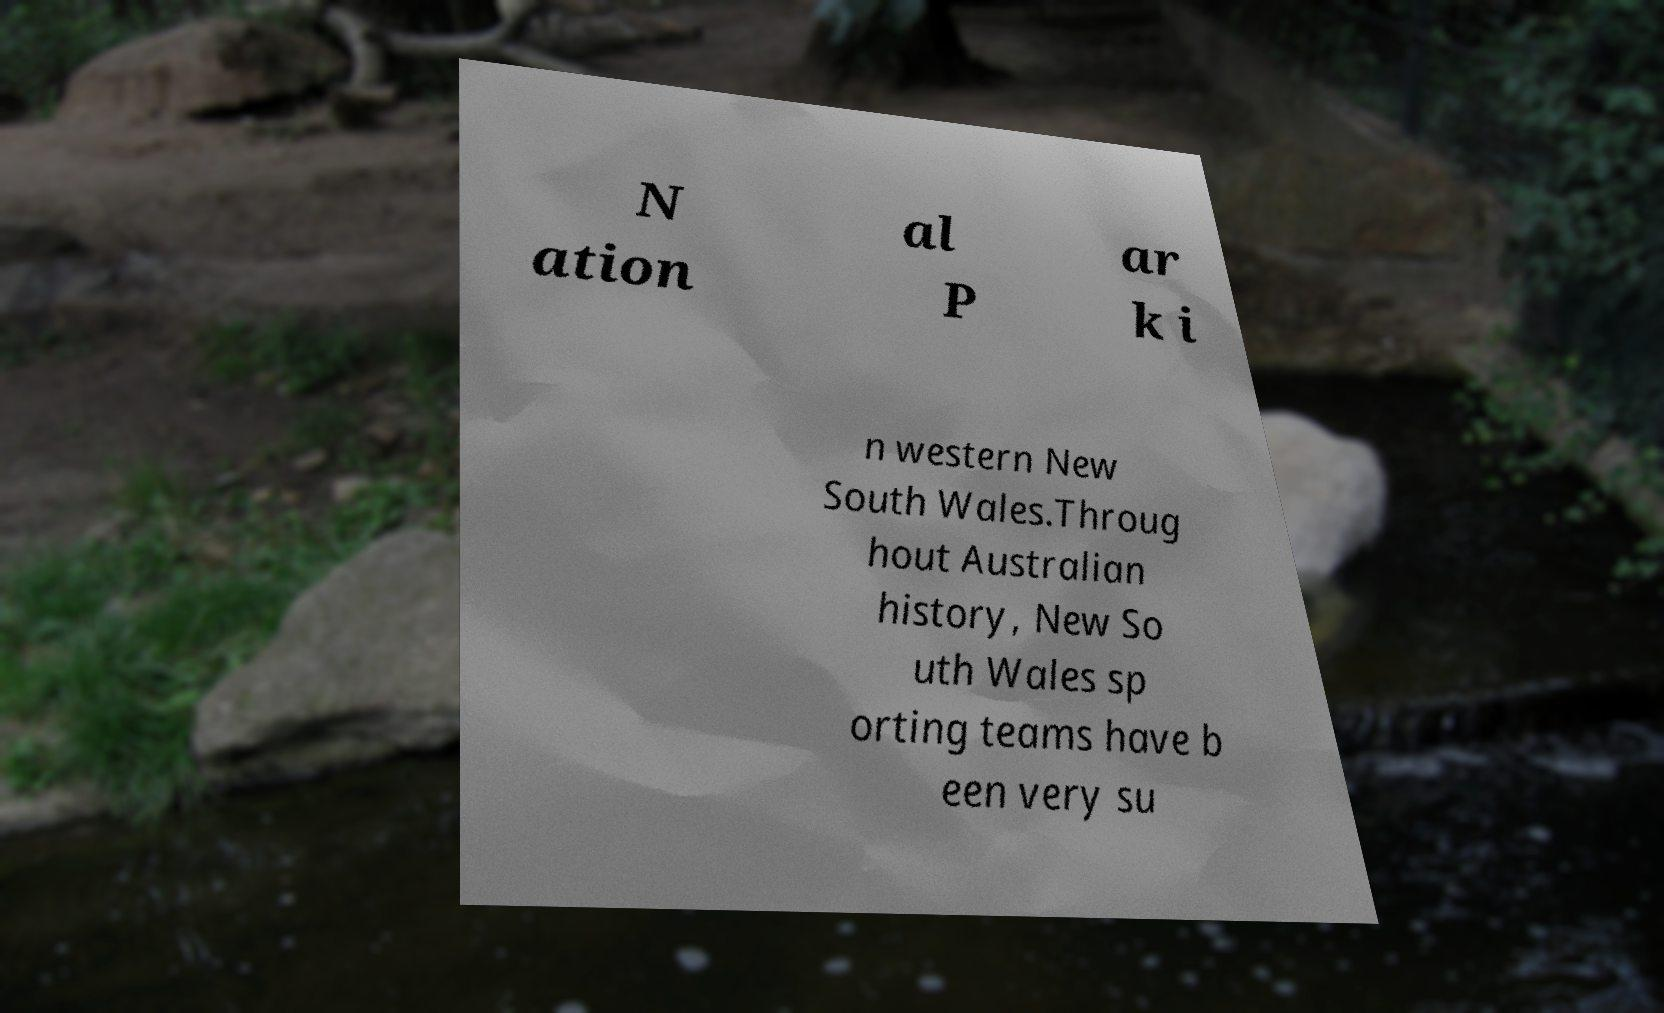Can you accurately transcribe the text from the provided image for me? N ation al P ar k i n western New South Wales.Throug hout Australian history, New So uth Wales sp orting teams have b een very su 